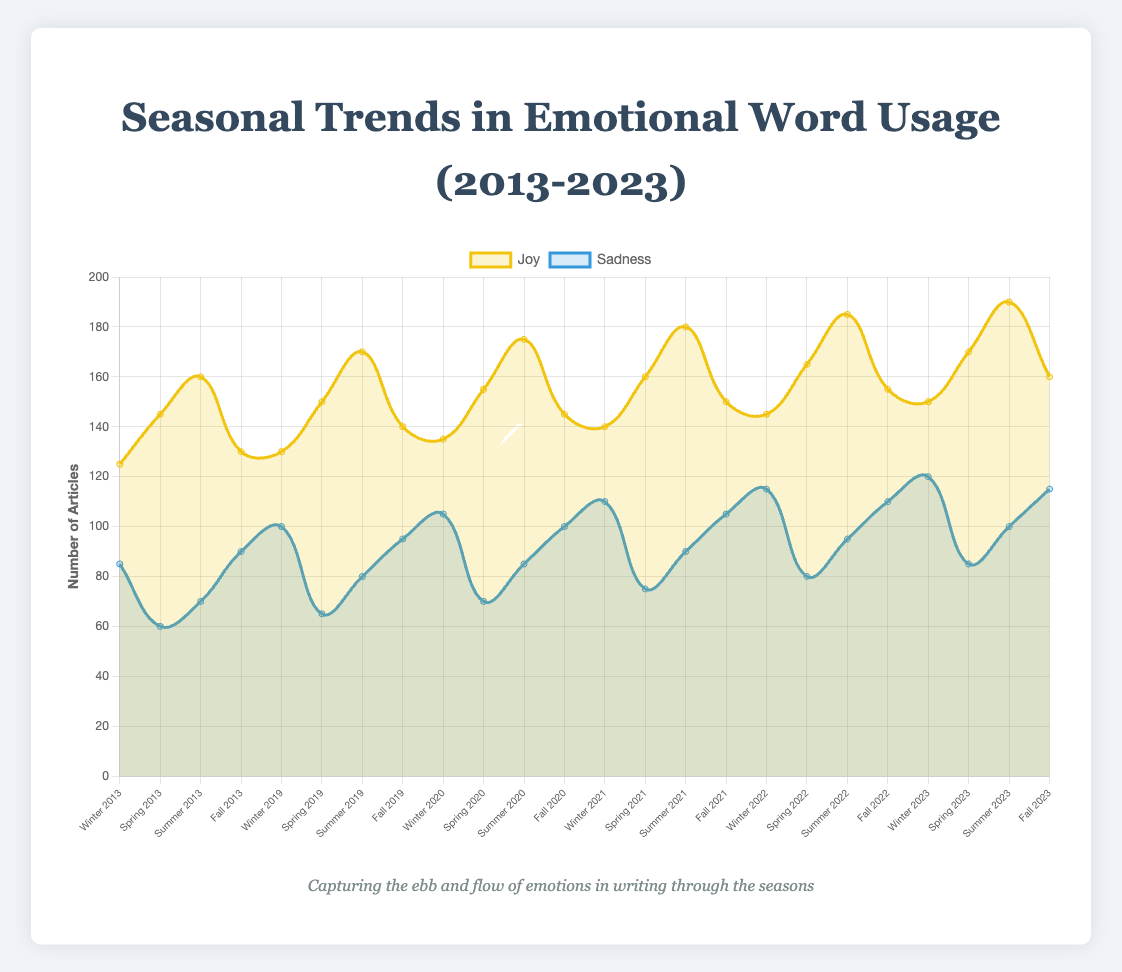What's the trend of joy-related articles from Winter to Summer in 2023? To find the trend, look at the number of articles for "joy" in Winter, Spring, and Summer of 2023. Winter has 150 articles, Spring has 170 articles, and Summer has 190 articles. The trend shows an increase from Winter to Summer in 2023.
Answer: Increasing How does the number of sadness-related articles in Winter 2022 compare to Winter 2023? Look for the value of sadness-related articles in Winter 2022 and Winter 2023. Winter 2022 has 115 articles, while Winter 2023 has 120 articles. Comparing these values, there is a slight increase from Winter 2022 to Winter 2023.
Answer: Slightly increased What's the average number of joy-related articles published in all seasons of 2022? To calculate the average, sum up the number of joy-related articles across all four seasons in 2022 and divide by 4. The numbers are 145 (Winter) + 165 (Spring) + 185 (Summer) + 155 (Fall) = 650. Dividing by 4 gives the average: 650/4 = 162.5
Answer: 162.5 Which season in 2019 had the highest number of sadness-related articles? Look at the values for sadness-related articles in each season of 2019: Winter (100), Spring (65), Summer (80), and Fall (95). Winter has the highest number of sadness-related articles with 100 articles.
Answer: Winter What is the sum difference of joy-related and sadness-related articles published in Fall 2020? To find the sum difference, subtract the total number of sadness-related articles from the number of joy-related articles in Fall 2020. For Fall 2020, joy-related articles are 145, and sadness-related articles are 100. The sum difference is 145 - 100 = 45.
Answer: 45 Is there a season where sadness-related articles consistently increase every year from 2013 to 2023? Check the data for sadness-related articles in each season from 2013 to 2023. For Winter, the numbers are 2013: 85, 2019: 100, 2020: 105, 2021: 110, 2022: 115, 2023: 120, showing a consistent increase every year.
Answer: Winter Compare the total number of joy-related articles in Summer 2021 and Summer 2023. Check the values for joy-related articles in Summer 2021 (180) and Summer 2023 (190). Summer 2023 has more joy-related articles compared to Summer 2021.
Answer: Summer 2023 has more What's the difference in the total number of articles mentioning joy between Fall 2013 and Fall 2023? Find the number of joy articles in Fall 2013 and Fall 2023. In Fall 2013, there are 130 articles, and in Fall 2023, there are 160. The difference is 160 - 130 = 30.
Answer: 30 Are joy-related articles in Spring 2013 higher or lower compared to Spring 2023? Check the values for joy-related articles in Spring 2013 (145) and Spring 2023 (170). Spring 2023 has a higher number of joy-related articles compared to Spring 2013.
Answer: Higher What is the visual difference between the trends of joy and sadness related articles? Joy-related articles are depicted as a yellow line, while sadness-related articles are depicted as a blue line. Joy articles generally trend higher and increase steadily across seasons and years, while sadness articles show less increase with some fluctuations.
Answer: Joy increases steadily, sadness fluctuates 